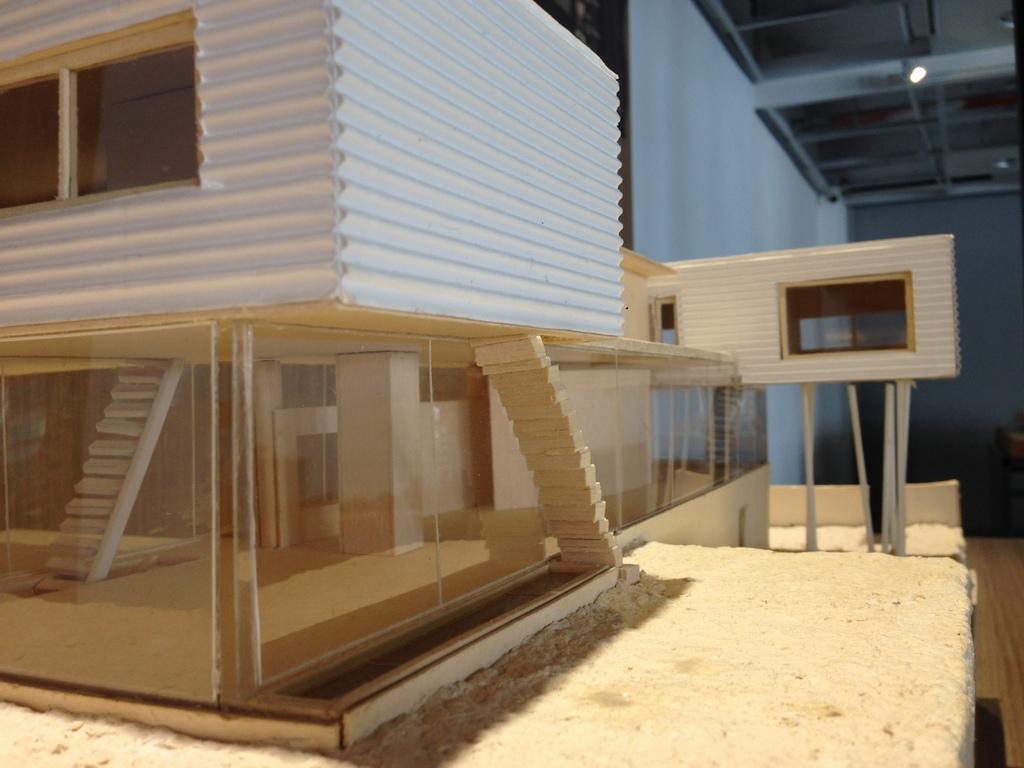How would you summarize this image in a sentence or two? In this picture I can see the building. On the right I can see the shed and wall. In the top right there is a light. 